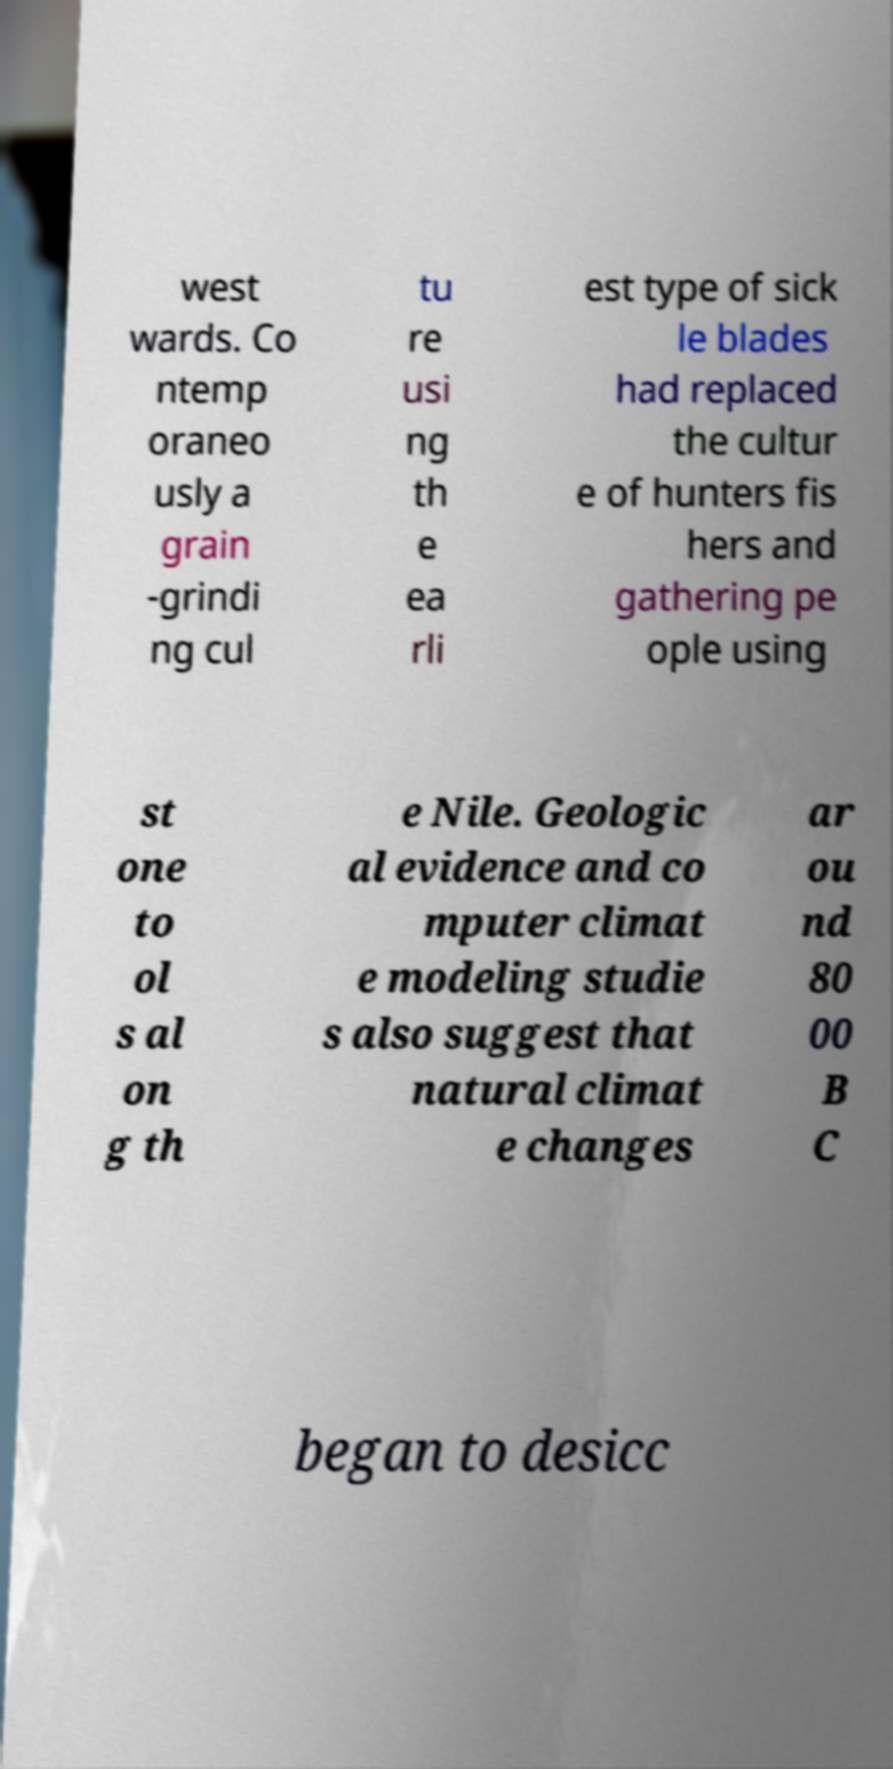There's text embedded in this image that I need extracted. Can you transcribe it verbatim? west wards. Co ntemp oraneo usly a grain -grindi ng cul tu re usi ng th e ea rli est type of sick le blades had replaced the cultur e of hunters fis hers and gathering pe ople using st one to ol s al on g th e Nile. Geologic al evidence and co mputer climat e modeling studie s also suggest that natural climat e changes ar ou nd 80 00 B C began to desicc 